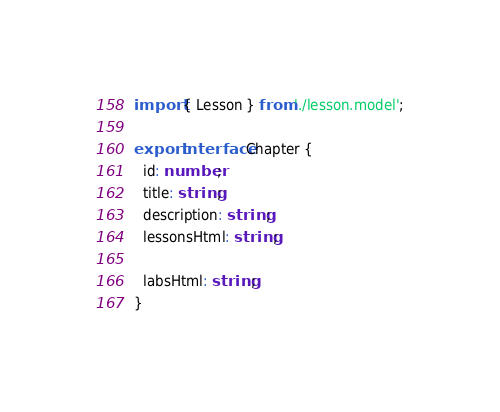<code> <loc_0><loc_0><loc_500><loc_500><_TypeScript_>import { Lesson } from './lesson.model';

export interface Chapter {
  id: number;
  title: string;
  description: string;
  lessonsHtml: string;

  labsHtml: string;
}
</code> 